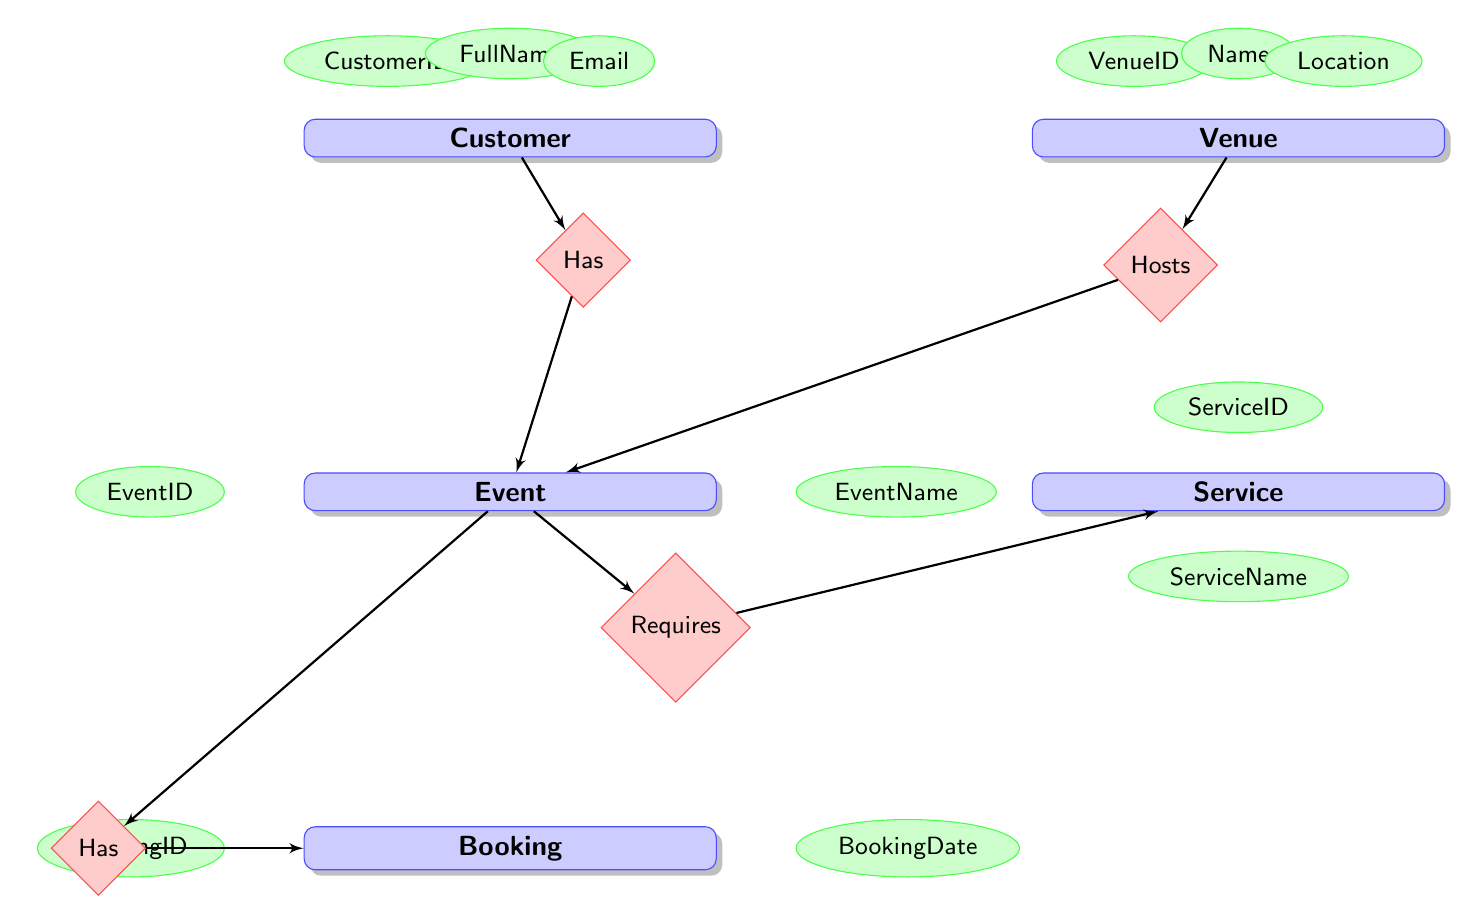What are the attributes of the Customer entity? The Customer entity has three attributes: CustomerID, FullName, Email, and Phone. These are the specific details that describe a Customer in this diagram.
Answer: CustomerID, FullName, Email, Phone How many entities are represented in the diagram? The diagram displays five distinct entities: Customer, Venue, Event, Booking, and Service. Counting these gives a total of five entities.
Answer: Five What type of relationship exists between Customer and Event? The diagram indicates a one-to-many relationship from Customer to Event, meaning one customer can host multiple events but each event is related to only one customer.
Answer: One-to-Many What is the primary key of the Venue entity? In the Venue entity, the primary key is VenueID, which uniquely identifies each venue in the system.
Answer: VenueID Which entity is required for EventService? The Event entity is required for EventService as it creates a one-to-many relationship where multiple services can be associated with a single event. To fulfill this service requirement, the diagram shows that EventService is linked to Event.
Answer: Event What does the Booking entity represent in relation to Event? The Booking entity represents a one-to-one relationship with the Event entity, indicating that each event has a unique booking associated with it.
Answer: One-to-One What type of relationship does Service have with EventService? The diagram shows a one-to-many relationship between Service and EventService, which means each service can relate to multiple instances of EventService. This indicates multiple uses of a service for different events.
Answer: One-to-Many What is the number of attributes in the Event entity? The Event entity contains six attributes: EventID, CustomerID, VenueID, EventName, Date, and Time, which provide the necessary details for each event.
Answer: Six 